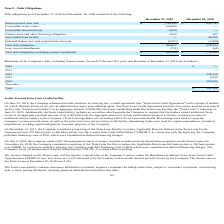From Chefs Wharehouse's financial document, What is the Senior secured term loan in 2019 and 2018 respectively? The document shows two values: $238,129 and $239,745. From the document: "Senior secured term loan $ 238,129 $ 239,745 Senior secured term loan $ 238,129 $ 239,745..." Also, What is the Total debt obligations in 2019 and 2018 respectively? The document shows two values: 386,827 and 278,230. From the document: "Total debt obligations 386,827 278,230 Total debt obligations 386,827 278,230..." Also, What is the Total debt obligations excluding current installments in 2019 and 2018 respectively? The document shows two values: $386,106 and $278,169. From the document: "debt obligations excluding current installments $ 386,106 $ 278,169 ations excluding current installments $ 386,106 $ 278,169..." Also, can you calculate: What is the average Senior secured term loan for 2018 and 2019? To answer this question, I need to perform calculations using the financial data. The calculation is: (238,129+ 239,745)/2, which equals 238937. This is based on the information: "Senior secured term loan $ 238,129 $ 239,745 Senior secured term loan $ 238,129 $ 239,745..." The key data points involved are: 238,129, 239,745. Additionally, Which year has the highest Senior secured term loan? According to the financial document, 2018. The relevant text states: "igations as of December 27, 2019 and December 28, 2018 consisted of the following:..." Also, can you calculate: What is the change in the value of Finance lease and other financing obligations between 2018 and 2019? Based on the calculation: 3,905-193, the result is 3712. This is based on the information: "nance lease and other financing obligations 3,905 193 Finance lease and other financing obligations 3,905 193..." The key data points involved are: 193, 3,905. 